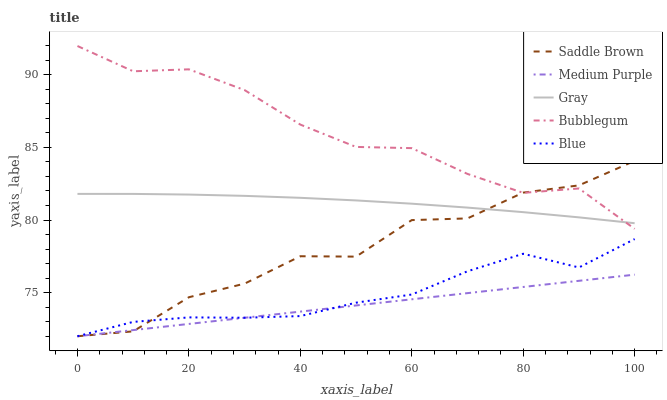Does Medium Purple have the minimum area under the curve?
Answer yes or no. Yes. Does Bubblegum have the maximum area under the curve?
Answer yes or no. Yes. Does Gray have the minimum area under the curve?
Answer yes or no. No. Does Gray have the maximum area under the curve?
Answer yes or no. No. Is Medium Purple the smoothest?
Answer yes or no. Yes. Is Saddle Brown the roughest?
Answer yes or no. Yes. Is Gray the smoothest?
Answer yes or no. No. Is Gray the roughest?
Answer yes or no. No. Does Medium Purple have the lowest value?
Answer yes or no. Yes. Does Gray have the lowest value?
Answer yes or no. No. Does Bubblegum have the highest value?
Answer yes or no. Yes. Does Gray have the highest value?
Answer yes or no. No. Is Medium Purple less than Bubblegum?
Answer yes or no. Yes. Is Bubblegum greater than Blue?
Answer yes or no. Yes. Does Saddle Brown intersect Blue?
Answer yes or no. Yes. Is Saddle Brown less than Blue?
Answer yes or no. No. Is Saddle Brown greater than Blue?
Answer yes or no. No. Does Medium Purple intersect Bubblegum?
Answer yes or no. No. 